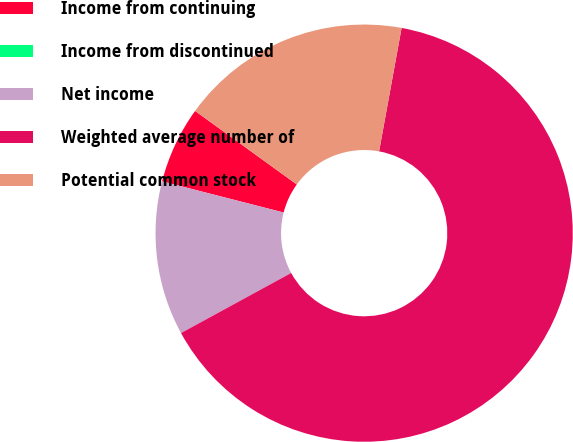Convert chart to OTSL. <chart><loc_0><loc_0><loc_500><loc_500><pie_chart><fcel>Income from continuing<fcel>Income from discontinued<fcel>Net income<fcel>Weighted average number of<fcel>Potential common stock<nl><fcel>5.97%<fcel>0.0%<fcel>11.94%<fcel>64.18%<fcel>17.91%<nl></chart> 